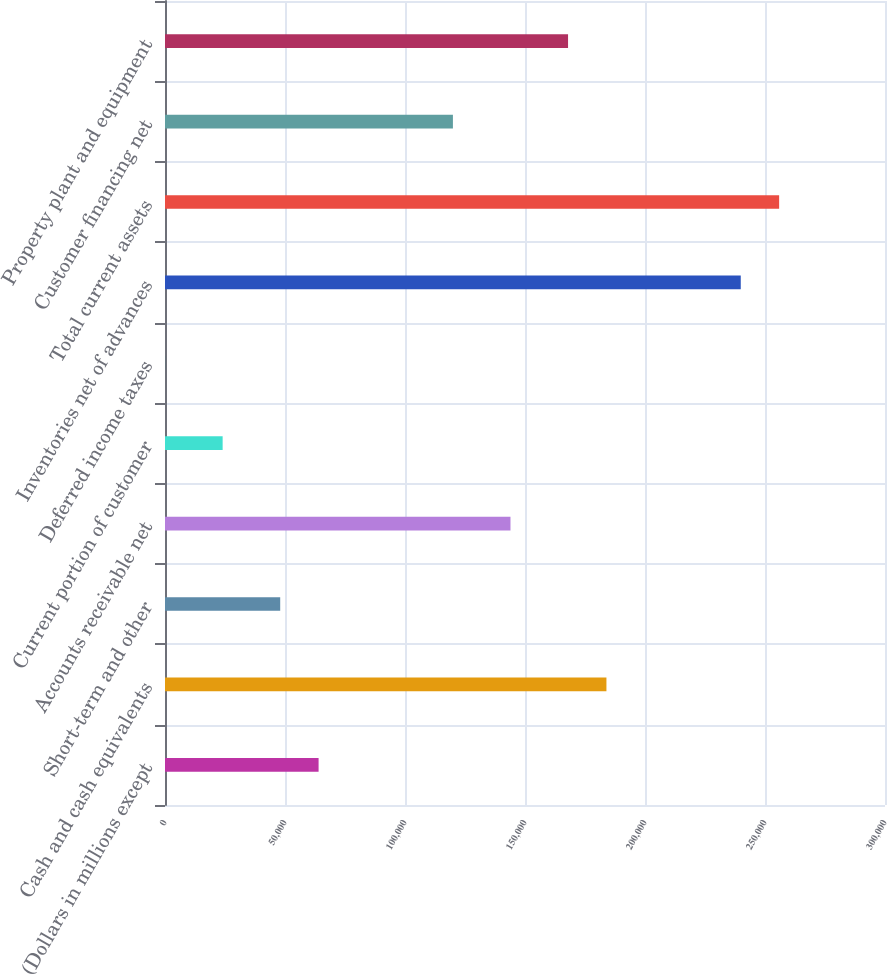<chart> <loc_0><loc_0><loc_500><loc_500><bar_chart><fcel>(Dollars in millions except<fcel>Cash and cash equivalents<fcel>Short-term and other<fcel>Accounts receivable net<fcel>Current portion of customer<fcel>Deferred income taxes<fcel>Inventories net of advances<fcel>Total current assets<fcel>Customer financing net<fcel>Property plant and equipment<nl><fcel>63994.6<fcel>183930<fcel>48003.2<fcel>143952<fcel>24016.1<fcel>29<fcel>239900<fcel>255891<fcel>119964<fcel>167939<nl></chart> 